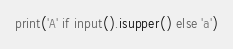Convert code to text. <code><loc_0><loc_0><loc_500><loc_500><_Python_>print('A' if input().isupper() else 'a')</code> 